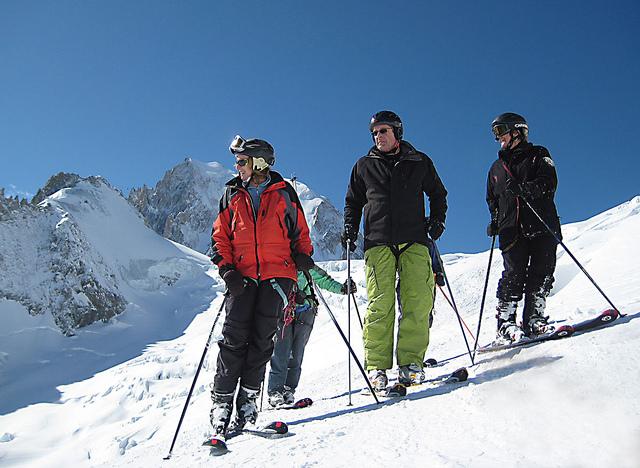How many clouds are in the sky?
Be succinct. 0. How many skiers are there?
Answer briefly. 4. Which direction are the skiers looking towards?
Short answer required. Downhill. 